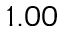Convert formula to latex. <formula><loc_0><loc_0><loc_500><loc_500>1 . 0 0</formula> 